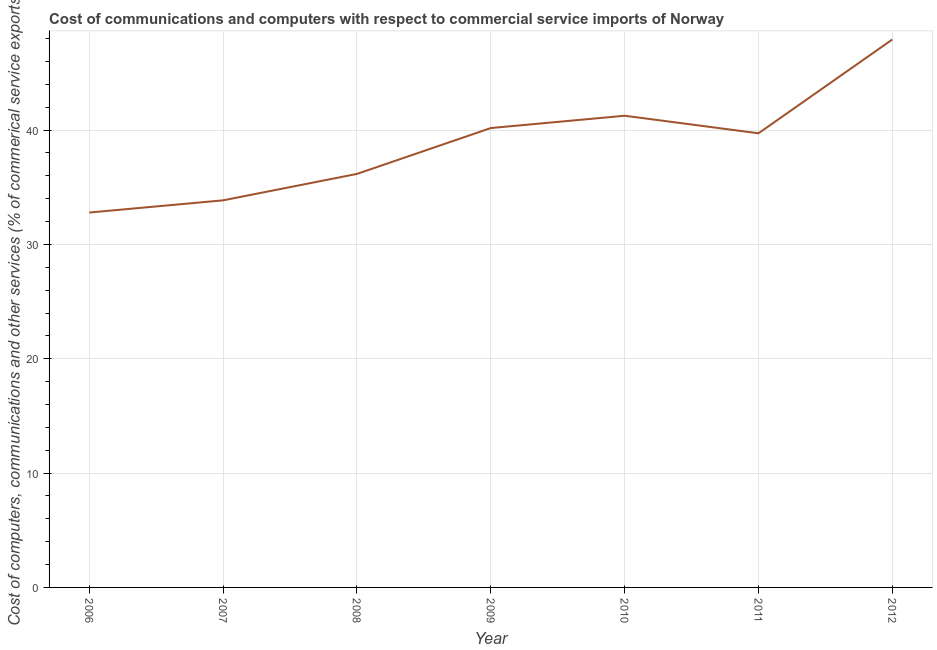What is the cost of communications in 2010?
Your response must be concise. 41.25. Across all years, what is the maximum cost of communications?
Your answer should be very brief. 47.92. Across all years, what is the minimum cost of communications?
Keep it short and to the point. 32.79. In which year was the  computer and other services minimum?
Give a very brief answer. 2006. What is the sum of the cost of communications?
Provide a succinct answer. 271.88. What is the difference between the  computer and other services in 2009 and 2010?
Your answer should be very brief. -1.08. What is the average cost of communications per year?
Make the answer very short. 38.84. What is the median  computer and other services?
Ensure brevity in your answer.  39.72. Do a majority of the years between 2006 and 2007 (inclusive) have  computer and other services greater than 26 %?
Your response must be concise. Yes. What is the ratio of the  computer and other services in 2006 to that in 2008?
Your answer should be compact. 0.91. What is the difference between the highest and the second highest cost of communications?
Your answer should be compact. 6.67. What is the difference between the highest and the lowest  computer and other services?
Provide a short and direct response. 15.14. In how many years, is the  computer and other services greater than the average  computer and other services taken over all years?
Your answer should be very brief. 4. What is the title of the graph?
Offer a terse response. Cost of communications and computers with respect to commercial service imports of Norway. What is the label or title of the Y-axis?
Your answer should be very brief. Cost of computers, communications and other services (% of commerical service exports). What is the Cost of computers, communications and other services (% of commerical service exports) of 2006?
Offer a very short reply. 32.79. What is the Cost of computers, communications and other services (% of commerical service exports) of 2007?
Provide a short and direct response. 33.86. What is the Cost of computers, communications and other services (% of commerical service exports) in 2008?
Ensure brevity in your answer.  36.17. What is the Cost of computers, communications and other services (% of commerical service exports) in 2009?
Provide a short and direct response. 40.18. What is the Cost of computers, communications and other services (% of commerical service exports) of 2010?
Offer a terse response. 41.25. What is the Cost of computers, communications and other services (% of commerical service exports) of 2011?
Your response must be concise. 39.72. What is the Cost of computers, communications and other services (% of commerical service exports) of 2012?
Offer a terse response. 47.92. What is the difference between the Cost of computers, communications and other services (% of commerical service exports) in 2006 and 2007?
Your response must be concise. -1.07. What is the difference between the Cost of computers, communications and other services (% of commerical service exports) in 2006 and 2008?
Offer a very short reply. -3.38. What is the difference between the Cost of computers, communications and other services (% of commerical service exports) in 2006 and 2009?
Provide a succinct answer. -7.39. What is the difference between the Cost of computers, communications and other services (% of commerical service exports) in 2006 and 2010?
Your response must be concise. -8.47. What is the difference between the Cost of computers, communications and other services (% of commerical service exports) in 2006 and 2011?
Make the answer very short. -6.93. What is the difference between the Cost of computers, communications and other services (% of commerical service exports) in 2006 and 2012?
Keep it short and to the point. -15.14. What is the difference between the Cost of computers, communications and other services (% of commerical service exports) in 2007 and 2008?
Provide a succinct answer. -2.31. What is the difference between the Cost of computers, communications and other services (% of commerical service exports) in 2007 and 2009?
Ensure brevity in your answer.  -6.32. What is the difference between the Cost of computers, communications and other services (% of commerical service exports) in 2007 and 2010?
Provide a short and direct response. -7.4. What is the difference between the Cost of computers, communications and other services (% of commerical service exports) in 2007 and 2011?
Ensure brevity in your answer.  -5.86. What is the difference between the Cost of computers, communications and other services (% of commerical service exports) in 2007 and 2012?
Your answer should be very brief. -14.07. What is the difference between the Cost of computers, communications and other services (% of commerical service exports) in 2008 and 2009?
Keep it short and to the point. -4.01. What is the difference between the Cost of computers, communications and other services (% of commerical service exports) in 2008 and 2010?
Provide a short and direct response. -5.09. What is the difference between the Cost of computers, communications and other services (% of commerical service exports) in 2008 and 2011?
Your answer should be very brief. -3.55. What is the difference between the Cost of computers, communications and other services (% of commerical service exports) in 2008 and 2012?
Provide a short and direct response. -11.76. What is the difference between the Cost of computers, communications and other services (% of commerical service exports) in 2009 and 2010?
Give a very brief answer. -1.08. What is the difference between the Cost of computers, communications and other services (% of commerical service exports) in 2009 and 2011?
Offer a terse response. 0.46. What is the difference between the Cost of computers, communications and other services (% of commerical service exports) in 2009 and 2012?
Offer a very short reply. -7.75. What is the difference between the Cost of computers, communications and other services (% of commerical service exports) in 2010 and 2011?
Your answer should be compact. 1.54. What is the difference between the Cost of computers, communications and other services (% of commerical service exports) in 2010 and 2012?
Ensure brevity in your answer.  -6.67. What is the difference between the Cost of computers, communications and other services (% of commerical service exports) in 2011 and 2012?
Offer a very short reply. -8.21. What is the ratio of the Cost of computers, communications and other services (% of commerical service exports) in 2006 to that in 2007?
Your response must be concise. 0.97. What is the ratio of the Cost of computers, communications and other services (% of commerical service exports) in 2006 to that in 2008?
Your answer should be very brief. 0.91. What is the ratio of the Cost of computers, communications and other services (% of commerical service exports) in 2006 to that in 2009?
Keep it short and to the point. 0.82. What is the ratio of the Cost of computers, communications and other services (% of commerical service exports) in 2006 to that in 2010?
Your answer should be compact. 0.8. What is the ratio of the Cost of computers, communications and other services (% of commerical service exports) in 2006 to that in 2011?
Make the answer very short. 0.83. What is the ratio of the Cost of computers, communications and other services (% of commerical service exports) in 2006 to that in 2012?
Your answer should be compact. 0.68. What is the ratio of the Cost of computers, communications and other services (% of commerical service exports) in 2007 to that in 2008?
Make the answer very short. 0.94. What is the ratio of the Cost of computers, communications and other services (% of commerical service exports) in 2007 to that in 2009?
Keep it short and to the point. 0.84. What is the ratio of the Cost of computers, communications and other services (% of commerical service exports) in 2007 to that in 2010?
Offer a terse response. 0.82. What is the ratio of the Cost of computers, communications and other services (% of commerical service exports) in 2007 to that in 2011?
Make the answer very short. 0.85. What is the ratio of the Cost of computers, communications and other services (% of commerical service exports) in 2007 to that in 2012?
Offer a terse response. 0.71. What is the ratio of the Cost of computers, communications and other services (% of commerical service exports) in 2008 to that in 2009?
Offer a terse response. 0.9. What is the ratio of the Cost of computers, communications and other services (% of commerical service exports) in 2008 to that in 2010?
Offer a terse response. 0.88. What is the ratio of the Cost of computers, communications and other services (% of commerical service exports) in 2008 to that in 2011?
Your response must be concise. 0.91. What is the ratio of the Cost of computers, communications and other services (% of commerical service exports) in 2008 to that in 2012?
Your answer should be very brief. 0.76. What is the ratio of the Cost of computers, communications and other services (% of commerical service exports) in 2009 to that in 2011?
Your response must be concise. 1.01. What is the ratio of the Cost of computers, communications and other services (% of commerical service exports) in 2009 to that in 2012?
Provide a short and direct response. 0.84. What is the ratio of the Cost of computers, communications and other services (% of commerical service exports) in 2010 to that in 2011?
Your answer should be very brief. 1.04. What is the ratio of the Cost of computers, communications and other services (% of commerical service exports) in 2010 to that in 2012?
Offer a very short reply. 0.86. What is the ratio of the Cost of computers, communications and other services (% of commerical service exports) in 2011 to that in 2012?
Your answer should be very brief. 0.83. 